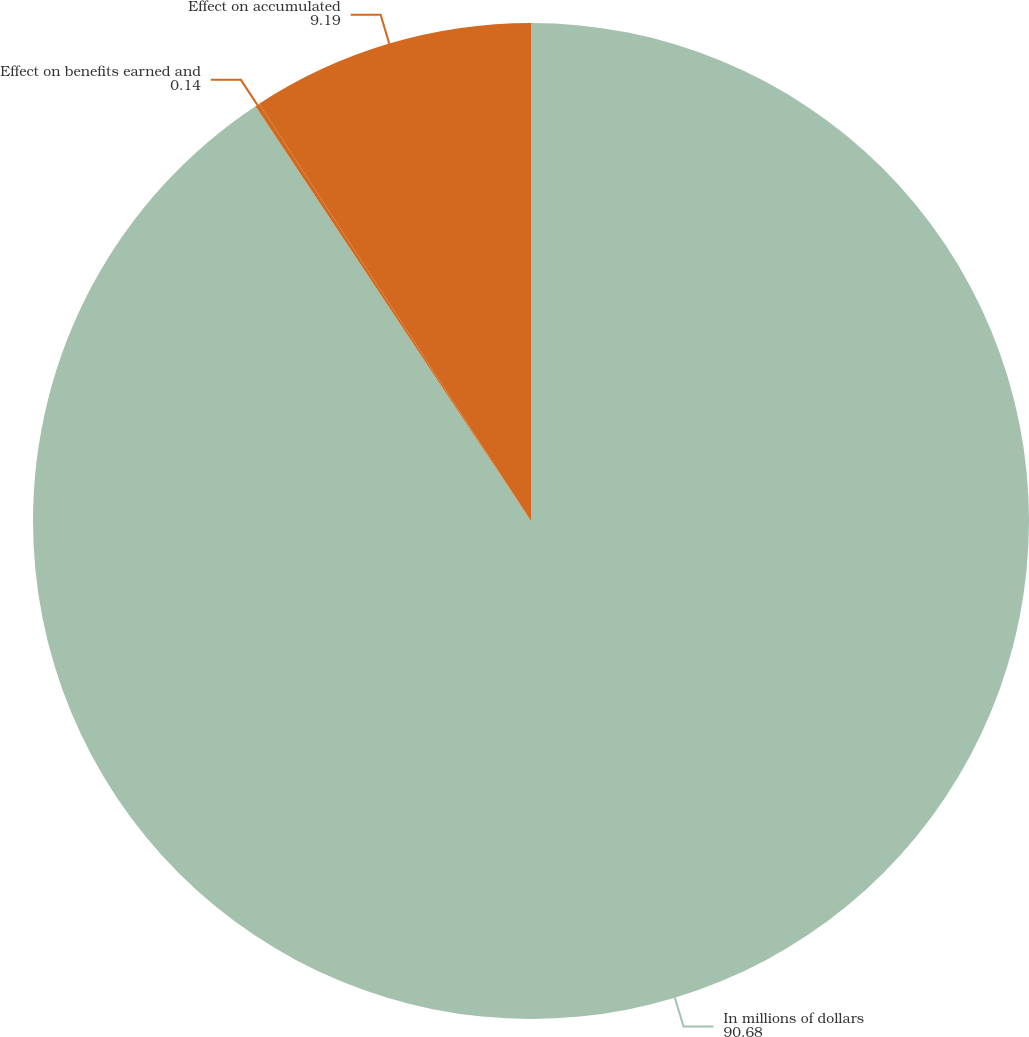Convert chart to OTSL. <chart><loc_0><loc_0><loc_500><loc_500><pie_chart><fcel>In millions of dollars<fcel>Effect on benefits earned and<fcel>Effect on accumulated<nl><fcel>90.68%<fcel>0.14%<fcel>9.19%<nl></chart> 